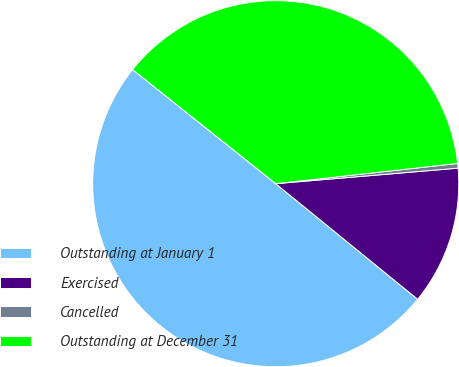Convert chart. <chart><loc_0><loc_0><loc_500><loc_500><pie_chart><fcel>Outstanding at January 1<fcel>Exercised<fcel>Cancelled<fcel>Outstanding at December 31<nl><fcel>49.83%<fcel>12.23%<fcel>0.41%<fcel>37.53%<nl></chart> 